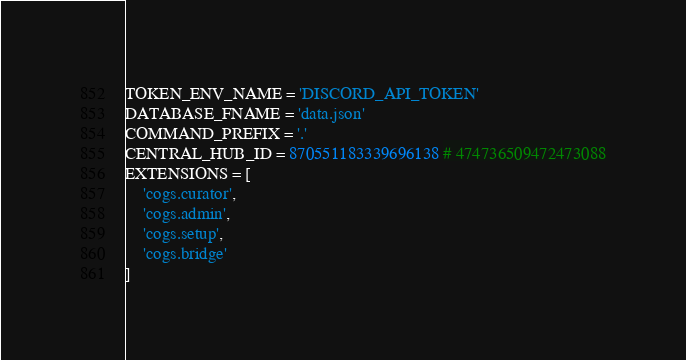<code> <loc_0><loc_0><loc_500><loc_500><_Python_>TOKEN_ENV_NAME = 'DISCORD_API_TOKEN'
DATABASE_FNAME = 'data.json'
COMMAND_PREFIX = '.'
CENTRAL_HUB_ID = 870551183339696138 # 474736509472473088
EXTENSIONS = [
    'cogs.curator',
    'cogs.admin',
    'cogs.setup',
    'cogs.bridge'
]
</code> 